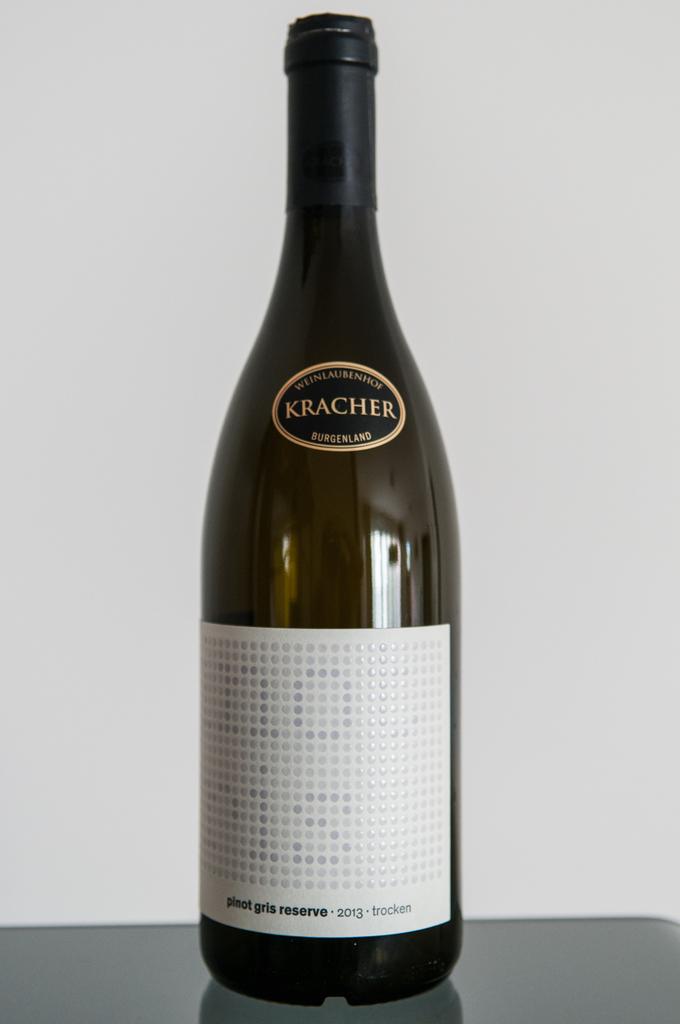What year is written on the bottom?
Offer a very short reply. 2013. 